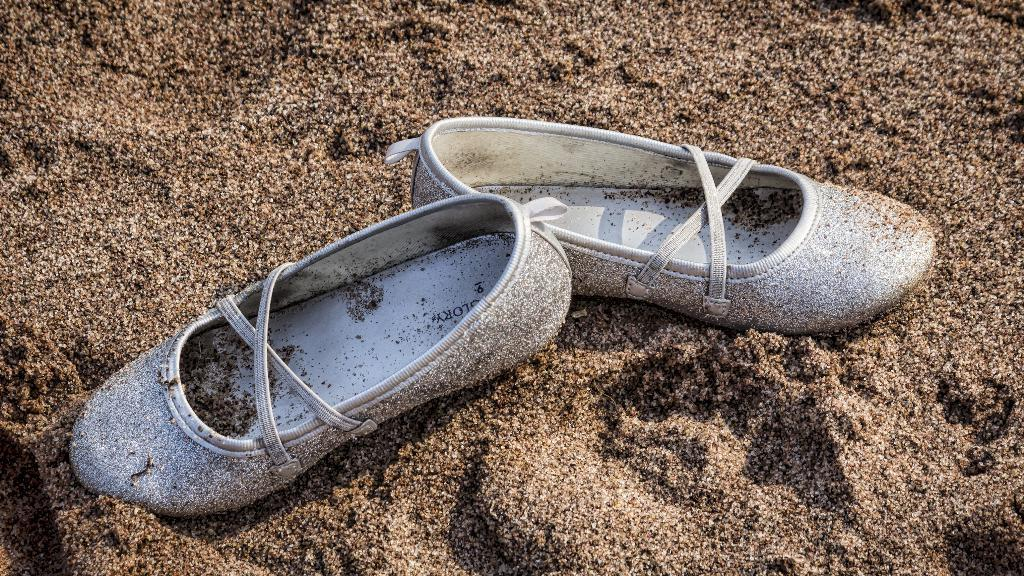What type of object is on the ground in the image? There is a pair of shoes on the ground in the image. Can you describe the position of the shoes in the image? The shoes are on the ground. What type of print is on the shoes in the image? There is no information about the print on the shoes in the image. 